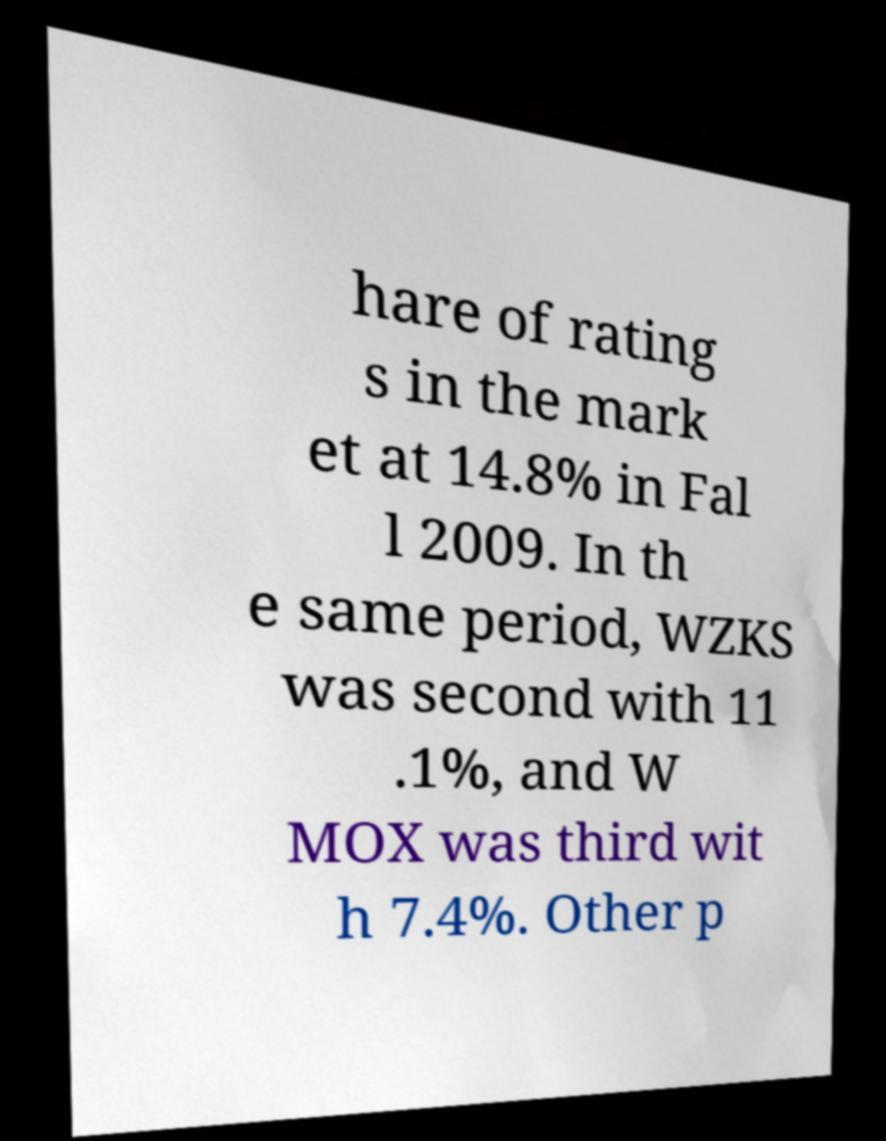Could you extract and type out the text from this image? hare of rating s in the mark et at 14.8% in Fal l 2009. In th e same period, WZKS was second with 11 .1%, and W MOX was third wit h 7.4%. Other p 